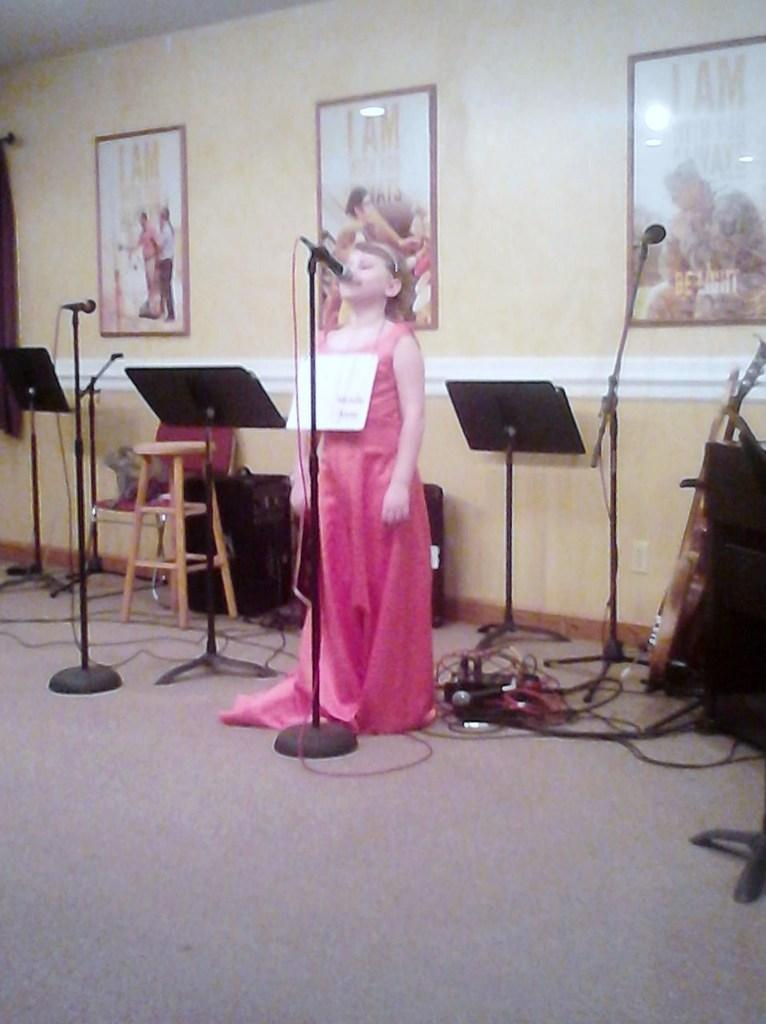Who is the main subject in the image? There is a girl in the image. What is the girl doing in the image? The girl is standing in front of a mic with a stand. What can be seen in the background of the image? There is a wall in the background of the image. What decorative elements are present on the wall? There are three photo frames on the wall. What type of news is being reported by the girl in the image? There is no indication in the image that the girl is reporting news, as she is simply standing in front of a mic with a stand. 